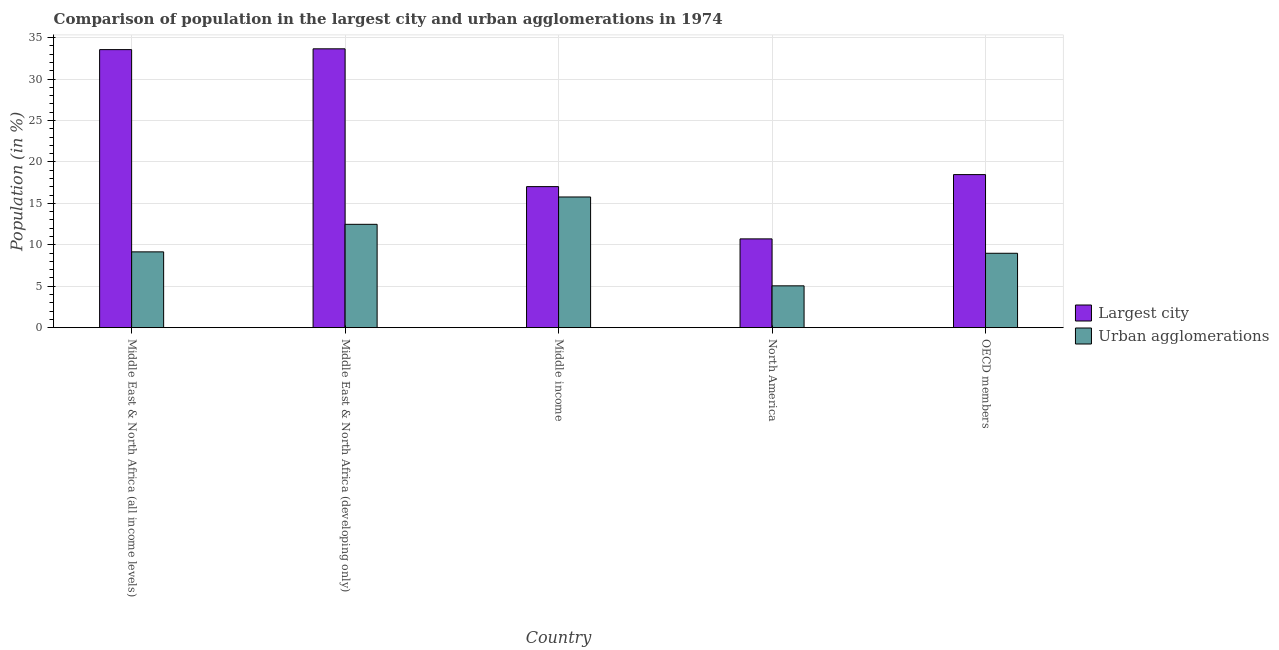How many groups of bars are there?
Provide a short and direct response. 5. Are the number of bars on each tick of the X-axis equal?
Provide a short and direct response. Yes. How many bars are there on the 3rd tick from the right?
Your answer should be compact. 2. What is the label of the 1st group of bars from the left?
Offer a very short reply. Middle East & North Africa (all income levels). In how many cases, is the number of bars for a given country not equal to the number of legend labels?
Make the answer very short. 0. What is the population in the largest city in OECD members?
Make the answer very short. 18.47. Across all countries, what is the maximum population in the largest city?
Ensure brevity in your answer.  33.65. Across all countries, what is the minimum population in the largest city?
Provide a succinct answer. 10.71. What is the total population in the largest city in the graph?
Make the answer very short. 113.42. What is the difference between the population in urban agglomerations in Middle income and that in OECD members?
Your response must be concise. 6.79. What is the difference between the population in the largest city in North America and the population in urban agglomerations in Middle East & North Africa (all income levels)?
Keep it short and to the point. 1.57. What is the average population in urban agglomerations per country?
Provide a succinct answer. 10.28. What is the difference between the population in urban agglomerations and population in the largest city in Middle income?
Offer a terse response. -1.25. What is the ratio of the population in the largest city in Middle income to that in OECD members?
Keep it short and to the point. 0.92. Is the difference between the population in urban agglomerations in Middle East & North Africa (developing only) and OECD members greater than the difference between the population in the largest city in Middle East & North Africa (developing only) and OECD members?
Offer a terse response. No. What is the difference between the highest and the second highest population in the largest city?
Ensure brevity in your answer.  0.1. What is the difference between the highest and the lowest population in urban agglomerations?
Offer a very short reply. 10.72. In how many countries, is the population in urban agglomerations greater than the average population in urban agglomerations taken over all countries?
Your response must be concise. 2. What does the 1st bar from the left in OECD members represents?
Your response must be concise. Largest city. What does the 2nd bar from the right in Middle East & North Africa (developing only) represents?
Your answer should be compact. Largest city. Are all the bars in the graph horizontal?
Provide a succinct answer. No. Are the values on the major ticks of Y-axis written in scientific E-notation?
Offer a terse response. No. Does the graph contain any zero values?
Your response must be concise. No. Does the graph contain grids?
Ensure brevity in your answer.  Yes. Where does the legend appear in the graph?
Offer a terse response. Center right. How many legend labels are there?
Give a very brief answer. 2. How are the legend labels stacked?
Offer a very short reply. Vertical. What is the title of the graph?
Offer a very short reply. Comparison of population in the largest city and urban agglomerations in 1974. What is the label or title of the X-axis?
Provide a short and direct response. Country. What is the label or title of the Y-axis?
Offer a very short reply. Population (in %). What is the Population (in %) of Largest city in Middle East & North Africa (all income levels)?
Offer a terse response. 33.56. What is the Population (in %) of Urban agglomerations in Middle East & North Africa (all income levels)?
Your answer should be compact. 9.15. What is the Population (in %) of Largest city in Middle East & North Africa (developing only)?
Make the answer very short. 33.65. What is the Population (in %) in Urban agglomerations in Middle East & North Africa (developing only)?
Provide a succinct answer. 12.47. What is the Population (in %) of Largest city in Middle income?
Offer a very short reply. 17.02. What is the Population (in %) in Urban agglomerations in Middle income?
Offer a terse response. 15.77. What is the Population (in %) in Largest city in North America?
Make the answer very short. 10.71. What is the Population (in %) in Urban agglomerations in North America?
Keep it short and to the point. 5.05. What is the Population (in %) of Largest city in OECD members?
Make the answer very short. 18.47. What is the Population (in %) of Urban agglomerations in OECD members?
Offer a very short reply. 8.98. Across all countries, what is the maximum Population (in %) of Largest city?
Your answer should be very brief. 33.65. Across all countries, what is the maximum Population (in %) of Urban agglomerations?
Keep it short and to the point. 15.77. Across all countries, what is the minimum Population (in %) of Largest city?
Offer a very short reply. 10.71. Across all countries, what is the minimum Population (in %) in Urban agglomerations?
Provide a succinct answer. 5.05. What is the total Population (in %) in Largest city in the graph?
Your answer should be compact. 113.42. What is the total Population (in %) of Urban agglomerations in the graph?
Ensure brevity in your answer.  51.42. What is the difference between the Population (in %) of Largest city in Middle East & North Africa (all income levels) and that in Middle East & North Africa (developing only)?
Your answer should be very brief. -0.1. What is the difference between the Population (in %) in Urban agglomerations in Middle East & North Africa (all income levels) and that in Middle East & North Africa (developing only)?
Ensure brevity in your answer.  -3.33. What is the difference between the Population (in %) in Largest city in Middle East & North Africa (all income levels) and that in Middle income?
Your answer should be compact. 16.53. What is the difference between the Population (in %) of Urban agglomerations in Middle East & North Africa (all income levels) and that in Middle income?
Your answer should be very brief. -6.62. What is the difference between the Population (in %) of Largest city in Middle East & North Africa (all income levels) and that in North America?
Give a very brief answer. 22.84. What is the difference between the Population (in %) in Urban agglomerations in Middle East & North Africa (all income levels) and that in North America?
Your answer should be very brief. 4.1. What is the difference between the Population (in %) of Largest city in Middle East & North Africa (all income levels) and that in OECD members?
Ensure brevity in your answer.  15.08. What is the difference between the Population (in %) of Urban agglomerations in Middle East & North Africa (all income levels) and that in OECD members?
Make the answer very short. 0.17. What is the difference between the Population (in %) of Largest city in Middle East & North Africa (developing only) and that in Middle income?
Ensure brevity in your answer.  16.63. What is the difference between the Population (in %) in Urban agglomerations in Middle East & North Africa (developing only) and that in Middle income?
Ensure brevity in your answer.  -3.3. What is the difference between the Population (in %) in Largest city in Middle East & North Africa (developing only) and that in North America?
Offer a very short reply. 22.94. What is the difference between the Population (in %) of Urban agglomerations in Middle East & North Africa (developing only) and that in North America?
Your answer should be compact. 7.43. What is the difference between the Population (in %) of Largest city in Middle East & North Africa (developing only) and that in OECD members?
Give a very brief answer. 15.18. What is the difference between the Population (in %) of Urban agglomerations in Middle East & North Africa (developing only) and that in OECD members?
Your answer should be compact. 3.5. What is the difference between the Population (in %) of Largest city in Middle income and that in North America?
Ensure brevity in your answer.  6.31. What is the difference between the Population (in %) of Urban agglomerations in Middle income and that in North America?
Offer a very short reply. 10.72. What is the difference between the Population (in %) of Largest city in Middle income and that in OECD members?
Offer a terse response. -1.45. What is the difference between the Population (in %) in Urban agglomerations in Middle income and that in OECD members?
Your response must be concise. 6.79. What is the difference between the Population (in %) of Largest city in North America and that in OECD members?
Offer a very short reply. -7.76. What is the difference between the Population (in %) of Urban agglomerations in North America and that in OECD members?
Your answer should be very brief. -3.93. What is the difference between the Population (in %) of Largest city in Middle East & North Africa (all income levels) and the Population (in %) of Urban agglomerations in Middle East & North Africa (developing only)?
Keep it short and to the point. 21.08. What is the difference between the Population (in %) of Largest city in Middle East & North Africa (all income levels) and the Population (in %) of Urban agglomerations in Middle income?
Offer a very short reply. 17.78. What is the difference between the Population (in %) of Largest city in Middle East & North Africa (all income levels) and the Population (in %) of Urban agglomerations in North America?
Ensure brevity in your answer.  28.51. What is the difference between the Population (in %) of Largest city in Middle East & North Africa (all income levels) and the Population (in %) of Urban agglomerations in OECD members?
Give a very brief answer. 24.58. What is the difference between the Population (in %) of Largest city in Middle East & North Africa (developing only) and the Population (in %) of Urban agglomerations in Middle income?
Provide a succinct answer. 17.88. What is the difference between the Population (in %) in Largest city in Middle East & North Africa (developing only) and the Population (in %) in Urban agglomerations in North America?
Your answer should be compact. 28.61. What is the difference between the Population (in %) of Largest city in Middle East & North Africa (developing only) and the Population (in %) of Urban agglomerations in OECD members?
Your response must be concise. 24.68. What is the difference between the Population (in %) in Largest city in Middle income and the Population (in %) in Urban agglomerations in North America?
Offer a very short reply. 11.97. What is the difference between the Population (in %) in Largest city in Middle income and the Population (in %) in Urban agglomerations in OECD members?
Keep it short and to the point. 8.04. What is the difference between the Population (in %) in Largest city in North America and the Population (in %) in Urban agglomerations in OECD members?
Ensure brevity in your answer.  1.74. What is the average Population (in %) in Largest city per country?
Ensure brevity in your answer.  22.68. What is the average Population (in %) in Urban agglomerations per country?
Your response must be concise. 10.28. What is the difference between the Population (in %) in Largest city and Population (in %) in Urban agglomerations in Middle East & North Africa (all income levels)?
Give a very brief answer. 24.41. What is the difference between the Population (in %) of Largest city and Population (in %) of Urban agglomerations in Middle East & North Africa (developing only)?
Your response must be concise. 21.18. What is the difference between the Population (in %) of Largest city and Population (in %) of Urban agglomerations in Middle income?
Give a very brief answer. 1.25. What is the difference between the Population (in %) in Largest city and Population (in %) in Urban agglomerations in North America?
Ensure brevity in your answer.  5.67. What is the difference between the Population (in %) of Largest city and Population (in %) of Urban agglomerations in OECD members?
Your answer should be compact. 9.5. What is the ratio of the Population (in %) in Urban agglomerations in Middle East & North Africa (all income levels) to that in Middle East & North Africa (developing only)?
Your answer should be very brief. 0.73. What is the ratio of the Population (in %) of Largest city in Middle East & North Africa (all income levels) to that in Middle income?
Your response must be concise. 1.97. What is the ratio of the Population (in %) of Urban agglomerations in Middle East & North Africa (all income levels) to that in Middle income?
Provide a short and direct response. 0.58. What is the ratio of the Population (in %) in Largest city in Middle East & North Africa (all income levels) to that in North America?
Your answer should be compact. 3.13. What is the ratio of the Population (in %) in Urban agglomerations in Middle East & North Africa (all income levels) to that in North America?
Provide a succinct answer. 1.81. What is the ratio of the Population (in %) of Largest city in Middle East & North Africa (all income levels) to that in OECD members?
Your answer should be compact. 1.82. What is the ratio of the Population (in %) of Urban agglomerations in Middle East & North Africa (all income levels) to that in OECD members?
Provide a short and direct response. 1.02. What is the ratio of the Population (in %) in Largest city in Middle East & North Africa (developing only) to that in Middle income?
Your answer should be very brief. 1.98. What is the ratio of the Population (in %) in Urban agglomerations in Middle East & North Africa (developing only) to that in Middle income?
Keep it short and to the point. 0.79. What is the ratio of the Population (in %) of Largest city in Middle East & North Africa (developing only) to that in North America?
Offer a very short reply. 3.14. What is the ratio of the Population (in %) in Urban agglomerations in Middle East & North Africa (developing only) to that in North America?
Ensure brevity in your answer.  2.47. What is the ratio of the Population (in %) in Largest city in Middle East & North Africa (developing only) to that in OECD members?
Provide a short and direct response. 1.82. What is the ratio of the Population (in %) of Urban agglomerations in Middle East & North Africa (developing only) to that in OECD members?
Give a very brief answer. 1.39. What is the ratio of the Population (in %) of Largest city in Middle income to that in North America?
Keep it short and to the point. 1.59. What is the ratio of the Population (in %) in Urban agglomerations in Middle income to that in North America?
Provide a succinct answer. 3.12. What is the ratio of the Population (in %) in Largest city in Middle income to that in OECD members?
Give a very brief answer. 0.92. What is the ratio of the Population (in %) of Urban agglomerations in Middle income to that in OECD members?
Give a very brief answer. 1.76. What is the ratio of the Population (in %) of Largest city in North America to that in OECD members?
Provide a short and direct response. 0.58. What is the ratio of the Population (in %) of Urban agglomerations in North America to that in OECD members?
Offer a terse response. 0.56. What is the difference between the highest and the second highest Population (in %) in Largest city?
Provide a succinct answer. 0.1. What is the difference between the highest and the second highest Population (in %) of Urban agglomerations?
Provide a succinct answer. 3.3. What is the difference between the highest and the lowest Population (in %) of Largest city?
Give a very brief answer. 22.94. What is the difference between the highest and the lowest Population (in %) in Urban agglomerations?
Ensure brevity in your answer.  10.72. 